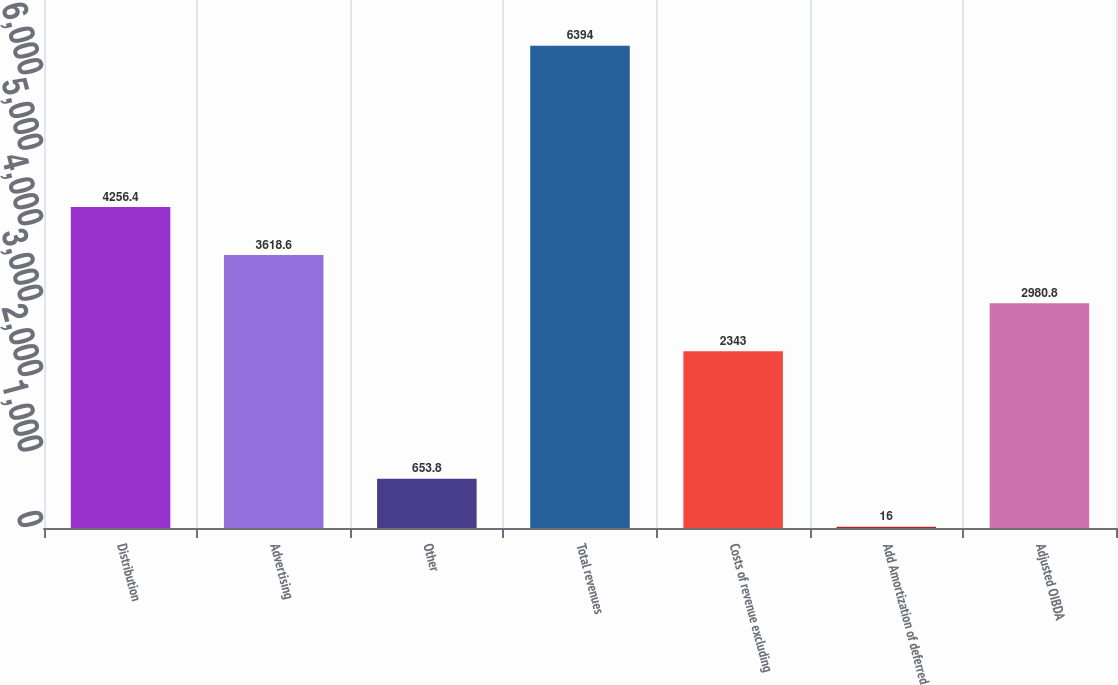Convert chart to OTSL. <chart><loc_0><loc_0><loc_500><loc_500><bar_chart><fcel>Distribution<fcel>Advertising<fcel>Other<fcel>Total revenues<fcel>Costs of revenue excluding<fcel>Add Amortization of deferred<fcel>Adjusted OIBDA<nl><fcel>4256.4<fcel>3618.6<fcel>653.8<fcel>6394<fcel>2343<fcel>16<fcel>2980.8<nl></chart> 